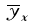Convert formula to latex. <formula><loc_0><loc_0><loc_500><loc_500>\overline { y } _ { x }</formula> 